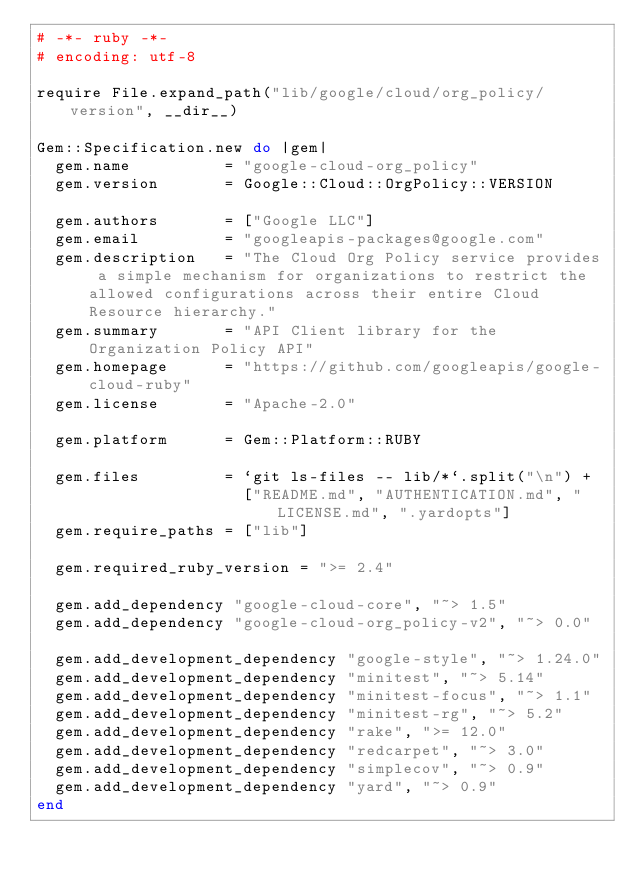<code> <loc_0><loc_0><loc_500><loc_500><_Ruby_># -*- ruby -*-
# encoding: utf-8

require File.expand_path("lib/google/cloud/org_policy/version", __dir__)

Gem::Specification.new do |gem|
  gem.name          = "google-cloud-org_policy"
  gem.version       = Google::Cloud::OrgPolicy::VERSION

  gem.authors       = ["Google LLC"]
  gem.email         = "googleapis-packages@google.com"
  gem.description   = "The Cloud Org Policy service provides a simple mechanism for organizations to restrict the allowed configurations across their entire Cloud Resource hierarchy."
  gem.summary       = "API Client library for the Organization Policy API"
  gem.homepage      = "https://github.com/googleapis/google-cloud-ruby"
  gem.license       = "Apache-2.0"

  gem.platform      = Gem::Platform::RUBY

  gem.files         = `git ls-files -- lib/*`.split("\n") +
                      ["README.md", "AUTHENTICATION.md", "LICENSE.md", ".yardopts"]
  gem.require_paths = ["lib"]

  gem.required_ruby_version = ">= 2.4"

  gem.add_dependency "google-cloud-core", "~> 1.5"
  gem.add_dependency "google-cloud-org_policy-v2", "~> 0.0"

  gem.add_development_dependency "google-style", "~> 1.24.0"
  gem.add_development_dependency "minitest", "~> 5.14"
  gem.add_development_dependency "minitest-focus", "~> 1.1"
  gem.add_development_dependency "minitest-rg", "~> 5.2"
  gem.add_development_dependency "rake", ">= 12.0"
  gem.add_development_dependency "redcarpet", "~> 3.0"
  gem.add_development_dependency "simplecov", "~> 0.9"
  gem.add_development_dependency "yard", "~> 0.9"
end
</code> 